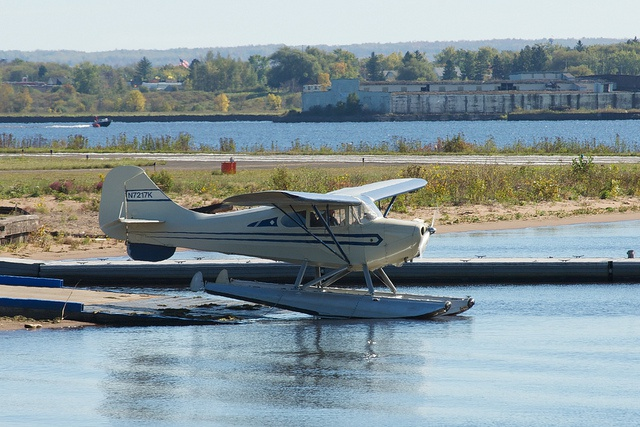Describe the objects in this image and their specific colors. I can see airplane in lightgray, gray, black, blue, and darkblue tones, boat in lightgray, navy, gray, and blue tones, and people in lightgray, black, gray, and purple tones in this image. 